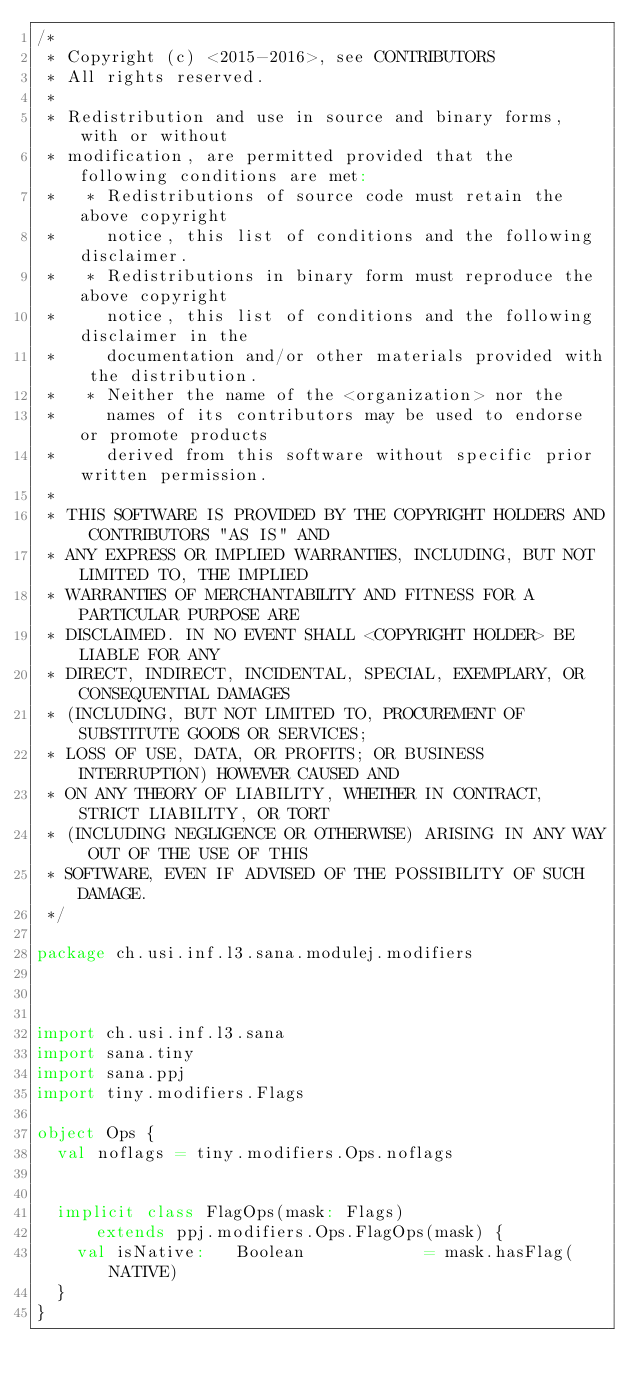Convert code to text. <code><loc_0><loc_0><loc_500><loc_500><_Scala_>/*
 * Copyright (c) <2015-2016>, see CONTRIBUTORS
 * All rights reserved.
 *
 * Redistribution and use in source and binary forms, with or without
 * modification, are permitted provided that the following conditions are met:
 *   * Redistributions of source code must retain the above copyright
 *     notice, this list of conditions and the following disclaimer.
 *   * Redistributions in binary form must reproduce the above copyright
 *     notice, this list of conditions and the following disclaimer in the
 *     documentation and/or other materials provided with the distribution.
 *   * Neither the name of the <organization> nor the
 *     names of its contributors may be used to endorse or promote products
 *     derived from this software without specific prior written permission.
 *
 * THIS SOFTWARE IS PROVIDED BY THE COPYRIGHT HOLDERS AND CONTRIBUTORS "AS IS" AND
 * ANY EXPRESS OR IMPLIED WARRANTIES, INCLUDING, BUT NOT LIMITED TO, THE IMPLIED
 * WARRANTIES OF MERCHANTABILITY AND FITNESS FOR A PARTICULAR PURPOSE ARE
 * DISCLAIMED. IN NO EVENT SHALL <COPYRIGHT HOLDER> BE LIABLE FOR ANY
 * DIRECT, INDIRECT, INCIDENTAL, SPECIAL, EXEMPLARY, OR CONSEQUENTIAL DAMAGES
 * (INCLUDING, BUT NOT LIMITED TO, PROCUREMENT OF SUBSTITUTE GOODS OR SERVICES;
 * LOSS OF USE, DATA, OR PROFITS; OR BUSINESS INTERRUPTION) HOWEVER CAUSED AND
 * ON ANY THEORY OF LIABILITY, WHETHER IN CONTRACT, STRICT LIABILITY, OR TORT
 * (INCLUDING NEGLIGENCE OR OTHERWISE) ARISING IN ANY WAY OUT OF THE USE OF THIS
 * SOFTWARE, EVEN IF ADVISED OF THE POSSIBILITY OF SUCH DAMAGE.
 */

package ch.usi.inf.l3.sana.modulej.modifiers



import ch.usi.inf.l3.sana
import sana.tiny
import sana.ppj
import tiny.modifiers.Flags

object Ops {
  val noflags = tiny.modifiers.Ops.noflags


  implicit class FlagOps(mask: Flags)
      extends ppj.modifiers.Ops.FlagOps(mask) {
    val isNative:   Boolean            = mask.hasFlag(NATIVE)
  }
}
</code> 